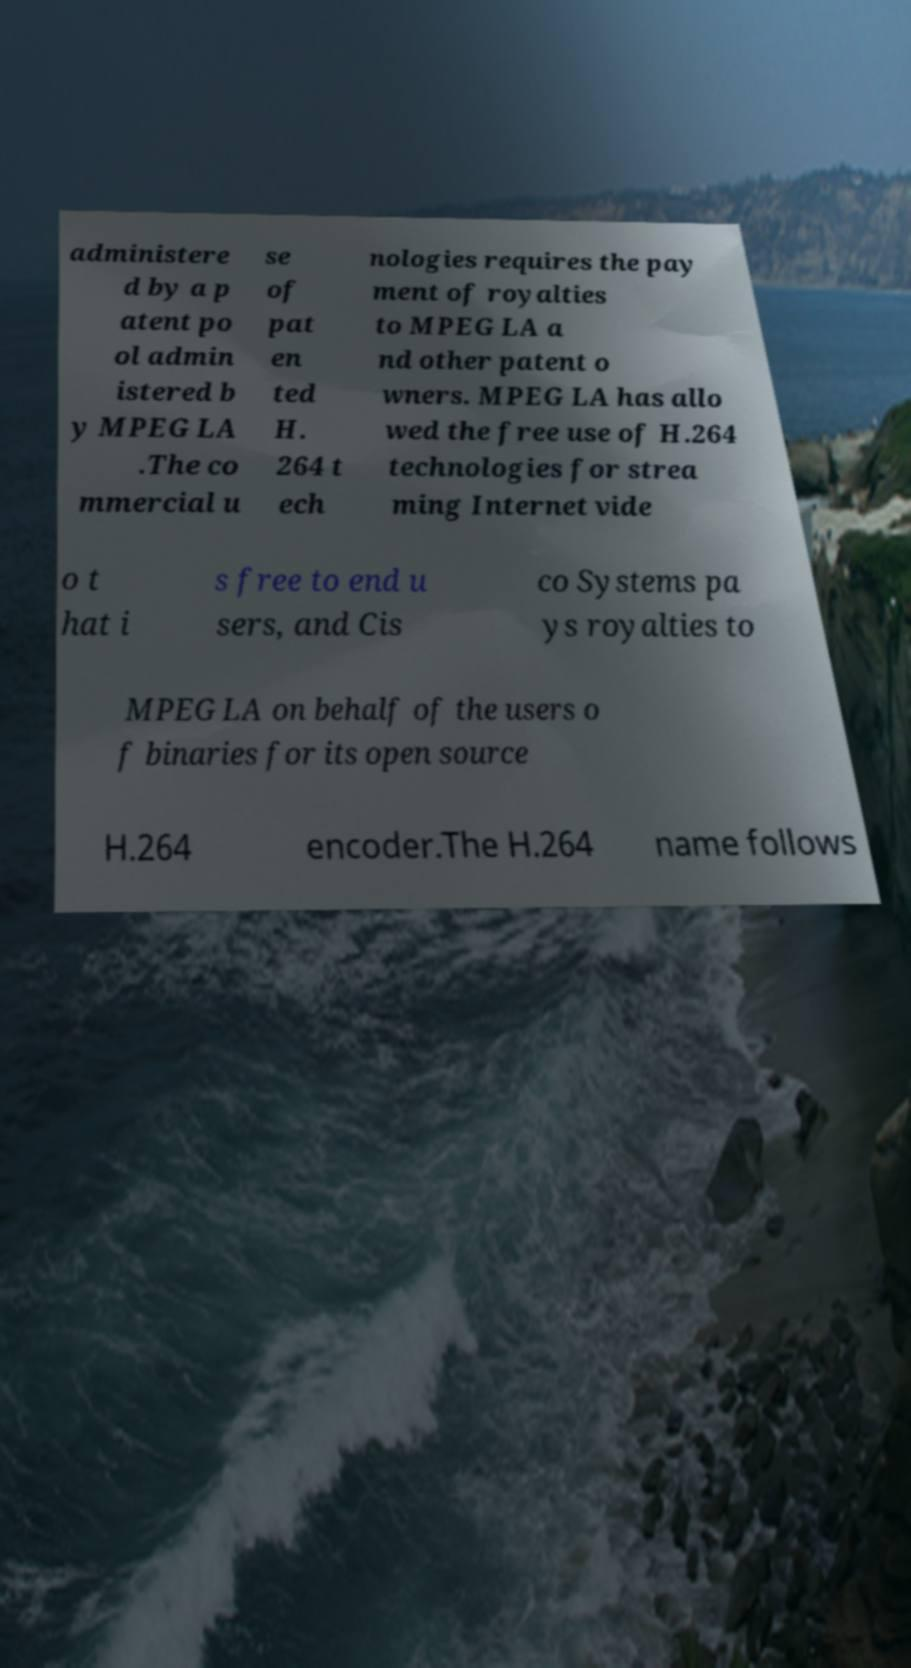What messages or text are displayed in this image? I need them in a readable, typed format. administere d by a p atent po ol admin istered b y MPEG LA .The co mmercial u se of pat en ted H. 264 t ech nologies requires the pay ment of royalties to MPEG LA a nd other patent o wners. MPEG LA has allo wed the free use of H.264 technologies for strea ming Internet vide o t hat i s free to end u sers, and Cis co Systems pa ys royalties to MPEG LA on behalf of the users o f binaries for its open source H.264 encoder.The H.264 name follows 